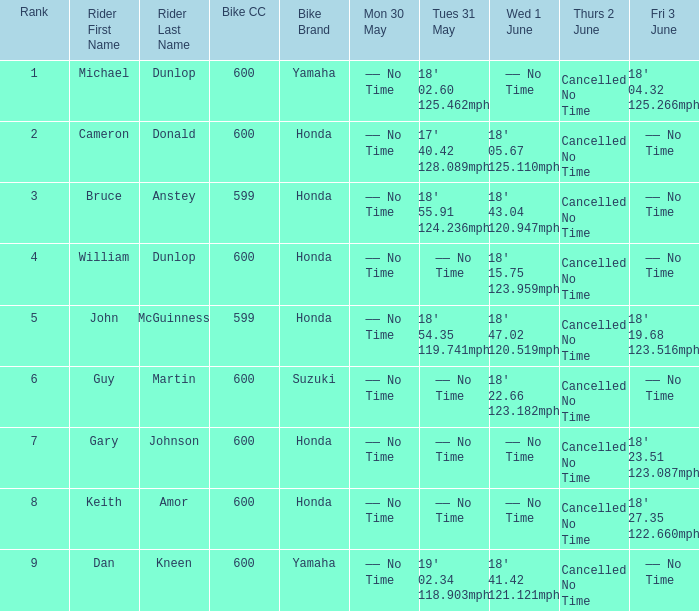What is the Fri 3 June time for the rider with a Weds 1 June time of 18' 22.66 123.182mph? —— No Time. 